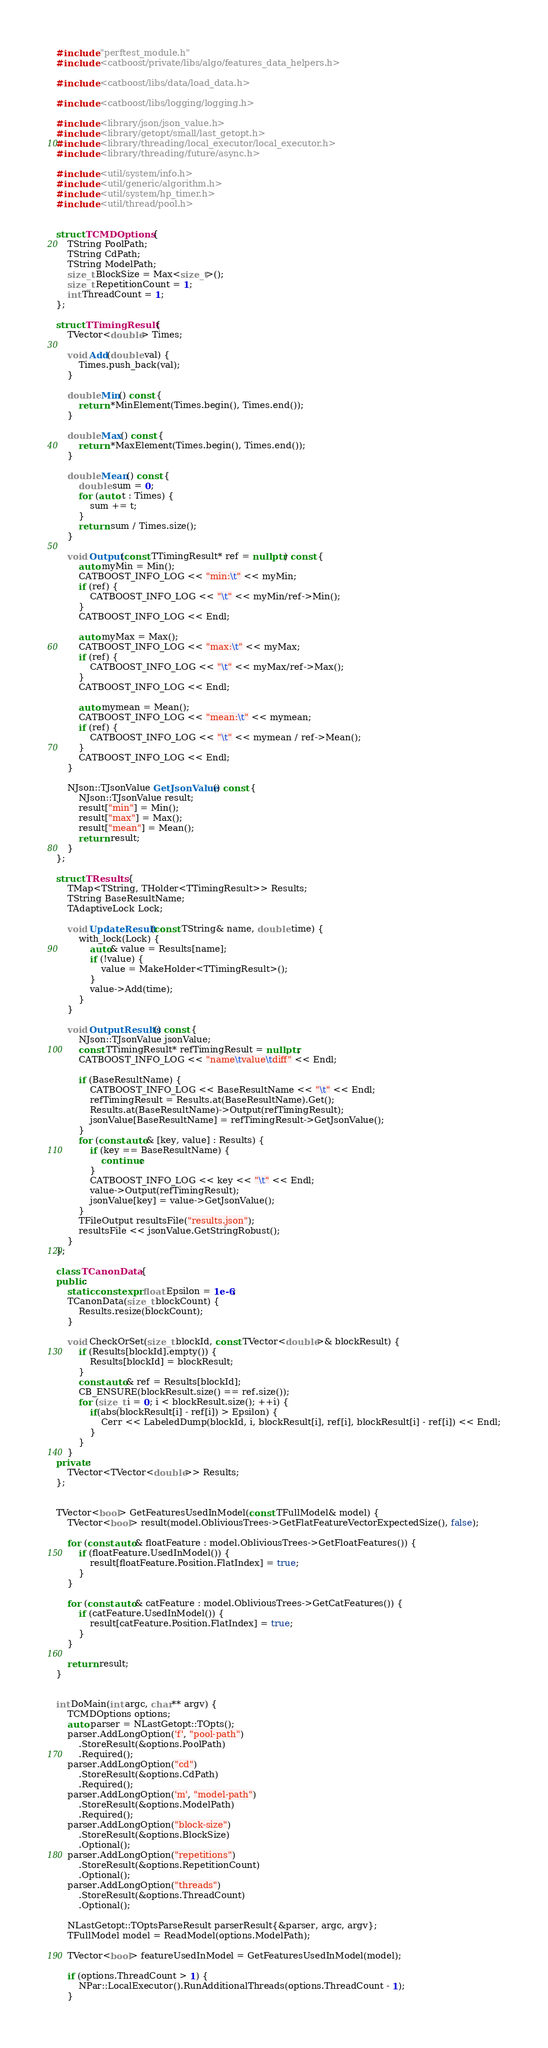Convert code to text. <code><loc_0><loc_0><loc_500><loc_500><_C++_>#include "perftest_module.h"
#include <catboost/private/libs/algo/features_data_helpers.h>

#include <catboost/libs/data/load_data.h>

#include <catboost/libs/logging/logging.h>

#include <library/json/json_value.h>
#include <library/getopt/small/last_getopt.h>
#include <library/threading/local_executor/local_executor.h>
#include <library/threading/future/async.h>

#include <util/system/info.h>
#include <util/generic/algorithm.h>
#include <util/system/hp_timer.h>
#include <util/thread/pool.h>


struct TCMDOptions {
    TString PoolPath;
    TString CdPath;
    TString ModelPath;
    size_t BlockSize = Max<size_t>();
    size_t RepetitionCount = 1;
    int ThreadCount = 1;
};

struct TTimingResult {
    TVector<double> Times;

    void Add(double val) {
        Times.push_back(val);
    }

    double Min() const {
        return *MinElement(Times.begin(), Times.end());
    }

    double Max() const {
        return *MaxElement(Times.begin(), Times.end());
    }

    double Mean() const {
        double sum = 0;
        for (auto t : Times) {
            sum += t;
        }
        return sum / Times.size();
    }

    void Output(const TTimingResult* ref = nullptr) const {
        auto myMin = Min();
        CATBOOST_INFO_LOG << "min:\t" << myMin;
        if (ref) {
            CATBOOST_INFO_LOG << "\t" << myMin/ref->Min();
        }
        CATBOOST_INFO_LOG << Endl;

        auto myMax = Max();
        CATBOOST_INFO_LOG << "max:\t" << myMax;
        if (ref) {
            CATBOOST_INFO_LOG << "\t" << myMax/ref->Max();
        }
        CATBOOST_INFO_LOG << Endl;

        auto mymean = Mean();
        CATBOOST_INFO_LOG << "mean:\t" << mymean;
        if (ref) {
            CATBOOST_INFO_LOG << "\t" << mymean / ref->Mean();
        }
        CATBOOST_INFO_LOG << Endl;
    }

    NJson::TJsonValue GetJsonValue() const {
        NJson::TJsonValue result;
        result["min"] = Min();
        result["max"] = Max();
        result["mean"] = Mean();
        return result;
    }
};

struct TResults {
    TMap<TString, THolder<TTimingResult>> Results;
    TString BaseResultName;
    TAdaptiveLock Lock;

    void UpdateResult(const TString& name, double time) {
        with_lock(Lock) {
            auto& value = Results[name];
            if (!value) {
                value = MakeHolder<TTimingResult>();
            }
            value->Add(time);
        }
    }

    void OutputResults() const {
        NJson::TJsonValue jsonValue;
        const TTimingResult* refTimingResult = nullptr;
        CATBOOST_INFO_LOG << "name\tvalue\tdiff" << Endl;

        if (BaseResultName) {
            CATBOOST_INFO_LOG << BaseResultName << "\t" << Endl;
            refTimingResult = Results.at(BaseResultName).Get();
            Results.at(BaseResultName)->Output(refTimingResult);
            jsonValue[BaseResultName] = refTimingResult->GetJsonValue();
        }
        for (const auto& [key, value] : Results) {
            if (key == BaseResultName) {
                continue;
            }
            CATBOOST_INFO_LOG << key << "\t" << Endl;
            value->Output(refTimingResult);
            jsonValue[key] = value->GetJsonValue();
        }
        TFileOutput resultsFile("results.json");
        resultsFile << jsonValue.GetStringRobust();
    }
};

class TCanonData {
public:
    static constexpr float Epsilon = 1e-6;
    TCanonData(size_t blockCount) {
        Results.resize(blockCount);
    }

    void CheckOrSet(size_t blockId, const TVector<double>& blockResult) {
        if (Results[blockId].empty()) {
            Results[blockId] = blockResult;
        }
        const auto& ref = Results[blockId];
        CB_ENSURE(blockResult.size() == ref.size());
        for (size_t i = 0; i < blockResult.size(); ++i) {
            if(abs(blockResult[i] - ref[i]) > Epsilon) {
                Cerr << LabeledDump(blockId, i, blockResult[i], ref[i], blockResult[i] - ref[i]) << Endl;
            }
        }
    }
private:
    TVector<TVector<double>> Results;
};


TVector<bool> GetFeaturesUsedInModel(const TFullModel& model) {
    TVector<bool> result(model.ObliviousTrees->GetFlatFeatureVectorExpectedSize(), false);

    for (const auto& floatFeature : model.ObliviousTrees->GetFloatFeatures()) {
        if (floatFeature.UsedInModel()) {
            result[floatFeature.Position.FlatIndex] = true;
        }
    }

    for (const auto& catFeature : model.ObliviousTrees->GetCatFeatures()) {
        if (catFeature.UsedInModel()) {
            result[catFeature.Position.FlatIndex] = true;
        }
    }

    return result;
}


int DoMain(int argc, char** argv) {
    TCMDOptions options;
    auto parser = NLastGetopt::TOpts();
    parser.AddLongOption('f', "pool-path")
        .StoreResult(&options.PoolPath)
        .Required();
    parser.AddLongOption("cd")
        .StoreResult(&options.CdPath)
        .Required();
    parser.AddLongOption('m', "model-path")
        .StoreResult(&options.ModelPath)
        .Required();
    parser.AddLongOption("block-size")
        .StoreResult(&options.BlockSize)
        .Optional();
    parser.AddLongOption("repetitions")
        .StoreResult(&options.RepetitionCount)
        .Optional();
    parser.AddLongOption("threads")
        .StoreResult(&options.ThreadCount)
        .Optional();

    NLastGetopt::TOptsParseResult parserResult{&parser, argc, argv};
    TFullModel model = ReadModel(options.ModelPath);

    TVector<bool> featureUsedInModel = GetFeaturesUsedInModel(model);

    if (options.ThreadCount > 1) {
        NPar::LocalExecutor().RunAdditionalThreads(options.ThreadCount - 1);
    }
</code> 